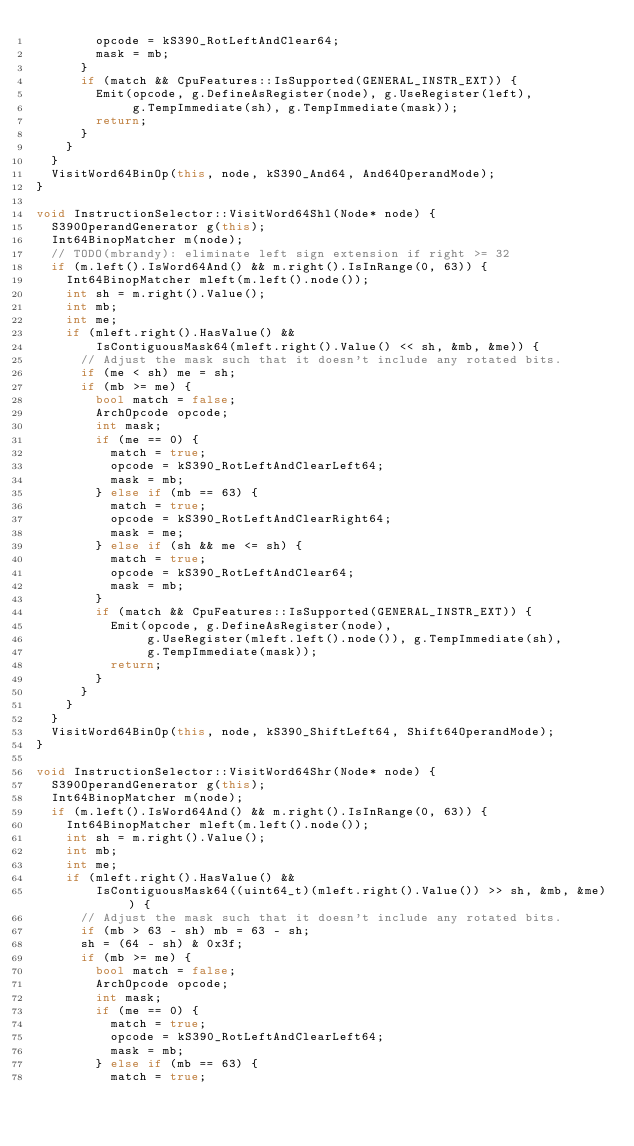Convert code to text. <code><loc_0><loc_0><loc_500><loc_500><_C++_>        opcode = kS390_RotLeftAndClear64;
        mask = mb;
      }
      if (match && CpuFeatures::IsSupported(GENERAL_INSTR_EXT)) {
        Emit(opcode, g.DefineAsRegister(node), g.UseRegister(left),
             g.TempImmediate(sh), g.TempImmediate(mask));
        return;
      }
    }
  }
  VisitWord64BinOp(this, node, kS390_And64, And64OperandMode);
}

void InstructionSelector::VisitWord64Shl(Node* node) {
  S390OperandGenerator g(this);
  Int64BinopMatcher m(node);
  // TODO(mbrandy): eliminate left sign extension if right >= 32
  if (m.left().IsWord64And() && m.right().IsInRange(0, 63)) {
    Int64BinopMatcher mleft(m.left().node());
    int sh = m.right().Value();
    int mb;
    int me;
    if (mleft.right().HasValue() &&
        IsContiguousMask64(mleft.right().Value() << sh, &mb, &me)) {
      // Adjust the mask such that it doesn't include any rotated bits.
      if (me < sh) me = sh;
      if (mb >= me) {
        bool match = false;
        ArchOpcode opcode;
        int mask;
        if (me == 0) {
          match = true;
          opcode = kS390_RotLeftAndClearLeft64;
          mask = mb;
        } else if (mb == 63) {
          match = true;
          opcode = kS390_RotLeftAndClearRight64;
          mask = me;
        } else if (sh && me <= sh) {
          match = true;
          opcode = kS390_RotLeftAndClear64;
          mask = mb;
        }
        if (match && CpuFeatures::IsSupported(GENERAL_INSTR_EXT)) {
          Emit(opcode, g.DefineAsRegister(node),
               g.UseRegister(mleft.left().node()), g.TempImmediate(sh),
               g.TempImmediate(mask));
          return;
        }
      }
    }
  }
  VisitWord64BinOp(this, node, kS390_ShiftLeft64, Shift64OperandMode);
}

void InstructionSelector::VisitWord64Shr(Node* node) {
  S390OperandGenerator g(this);
  Int64BinopMatcher m(node);
  if (m.left().IsWord64And() && m.right().IsInRange(0, 63)) {
    Int64BinopMatcher mleft(m.left().node());
    int sh = m.right().Value();
    int mb;
    int me;
    if (mleft.right().HasValue() &&
        IsContiguousMask64((uint64_t)(mleft.right().Value()) >> sh, &mb, &me)) {
      // Adjust the mask such that it doesn't include any rotated bits.
      if (mb > 63 - sh) mb = 63 - sh;
      sh = (64 - sh) & 0x3f;
      if (mb >= me) {
        bool match = false;
        ArchOpcode opcode;
        int mask;
        if (me == 0) {
          match = true;
          opcode = kS390_RotLeftAndClearLeft64;
          mask = mb;
        } else if (mb == 63) {
          match = true;</code> 